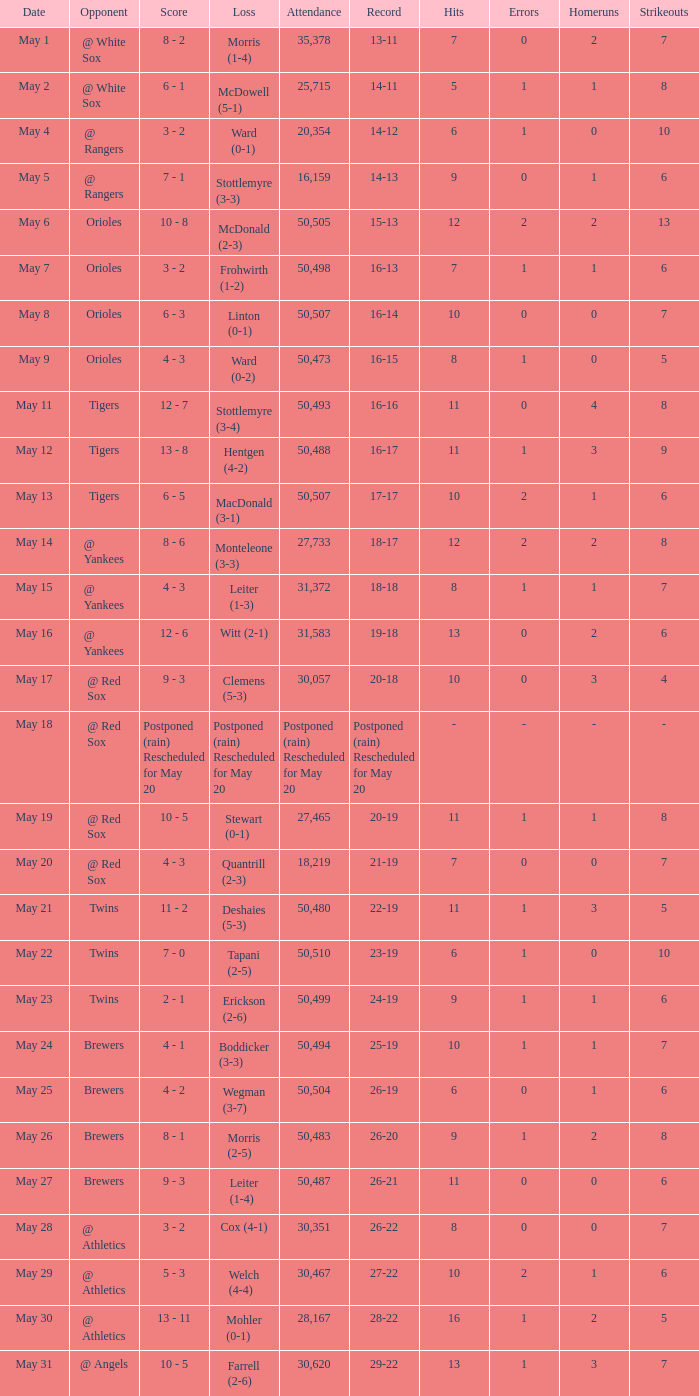On may 9, what was the outcome of the game? 4 - 3. 